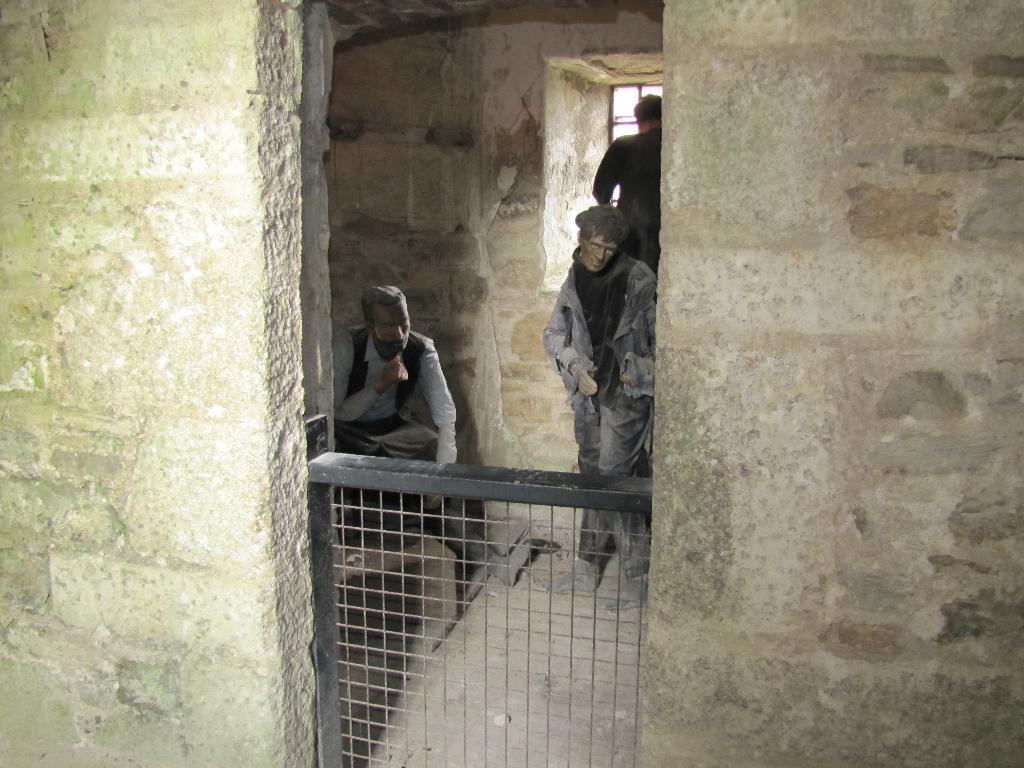Can you describe this image briefly? In the image there is a wall and in between the wall there is a room, inside that room there are two sculptures and behind the sculptures there is a person standing in front of the window. 